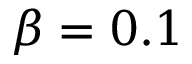<formula> <loc_0><loc_0><loc_500><loc_500>\beta = 0 . 1</formula> 